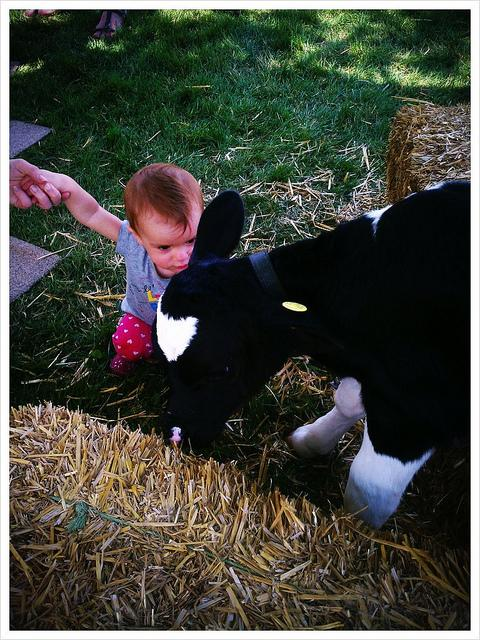What kind of food eater is the animal?

Choices:
A) carnivore
B) omnivore
C) herbivore
D) photosynthesis herbivore 